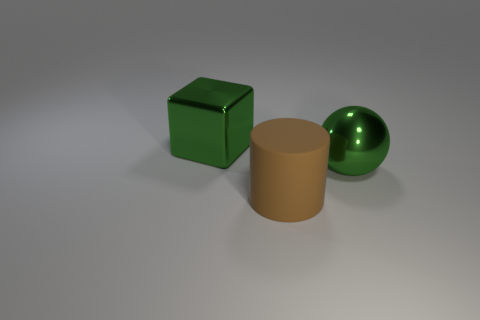Add 3 big green metal cylinders. How many objects exist? 6 Subtract 1 balls. How many balls are left? 0 Subtract all yellow spheres. Subtract all red cylinders. How many spheres are left? 1 Subtract 1 green cubes. How many objects are left? 2 Subtract all brown cylinders. How many gray cubes are left? 0 Subtract all big brown things. Subtract all cubes. How many objects are left? 1 Add 2 large blocks. How many large blocks are left? 3 Add 1 green metallic spheres. How many green metallic spheres exist? 2 